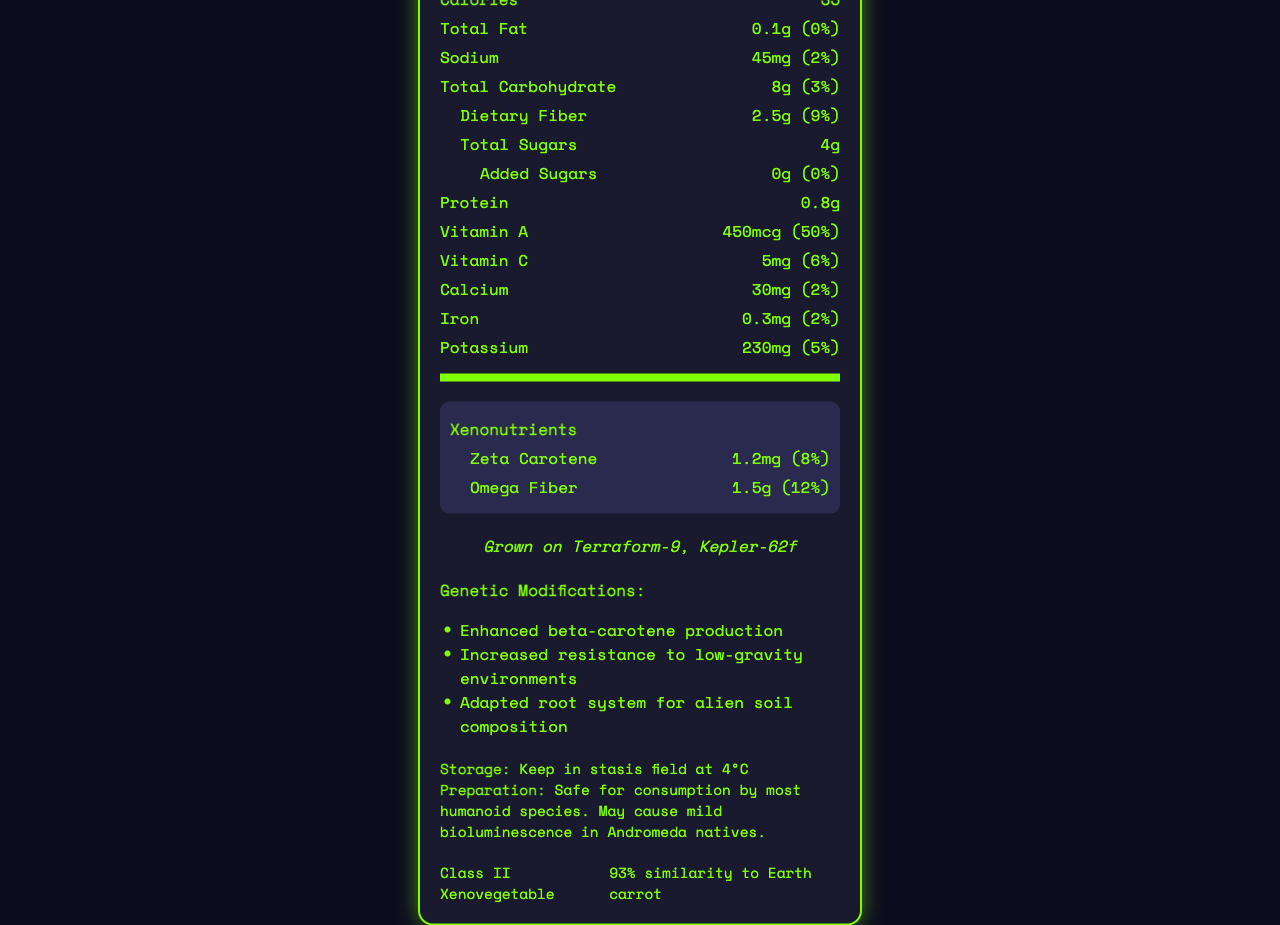what is the serving size for a Xenocarrot? Referring to the label, the serving size is clearly listed as "1 medium (85g)."
Answer: 1 medium (85g) how many calories are in one serving of a Xenocarrot? The document states that there are 35 calories in one serving of a Xenocarrot.
Answer: 35 what is the daily value percentage for dietary fiber per serving? The label shows that the dietary fiber content has a daily value percentage of 9%.
Answer: 9% which nutrient has the highest daily value percentage in a Xenocarrot? The document details various nutrients and their daily value percentages. Vitamin A has the highest at 50%.
Answer: Vitamin A what specific adaptation has been made to the Xenocarrot's root system? Under the genetic modifications section, the document lists "Adapted root system for alien soil composition."
Answer: Adapted root system for alien soil composition which planet is the Xenocarrot cultivated on? A. Terraform-9 B. Kepler-62f C. Mars D. Triton The document specifies that the Xenocarrot is "Grown on Terraform-9, Kepler-62f," indicating Terraform-9 is one of the cultivation locations, not just a planet.
Answer: A. Terraform-9 how much zeta carotene is in one serving, and what is its daily value percentage? A. 1.0mg, 6% B. 1.2mg, 10% C. 1.2mg, 8% D. 1.4mg, 12% The document notes that one serving contains 1.2mg of zeta carotene, which is 8% of the daily value.
Answer: C. 1.2mg, 8% can Andromeda natives safely consume the Xenocarrot without any side effects? The preparation suggestions mention that the Xenocarrot "May cause mild bioluminescence in Andromeda natives," indicating there are possible side effects.
Answer: No does the Xenocarrot have added sugars? According to the label, the Xenocarrot contains 0g of added sugars.
Answer: No summarize the main nutritional information and special details of a Xenocarrot. The document furnishes comprehensive nutritional details, genetic modifications, and special characteristics of the Xenocarrot.
Answer: The Xenocarrot provides 35 calories per serving and contains various nutrients like Vitamin A, Vitamin C, Calcium, and Iron. It is genetically modified for enhanced beta-carotene production, resistance to low-gravity environments, and soil adaptation. It includes unique xenonutrients like zeta carotene and omega fiber. Grown on Terraform-9, this vegetable is for interstellar trade and has a 93% similarity to Earth carrots. how much potassium is found in one serving of Xenocarrot? The label indicates that there are 230mg of potassium per serving, which is 5% of the daily value.
Answer: 230mg what is the storage temperature mentioned for the Xenocarrot? A. 2°C B. 4°C C. 6°C D. 0°C The storage instructions specify to "Keep in stasis field at 4°C."
Answer: B. 4°C what is the Terra Equivalence Rating of the Xenocarrot? The document specifies that the Terra Equivalence Rating is 93%, showing its similarity to an Earth carrot.
Answer: 93% what is the protein content per serving of a Xenocarrot? According to the document, each serving contains 0.8g of protein.
Answer: 0.8g who can safely consume a Xenocarrot? The preparation suggestion notes it is "Safe for consumption by most humanoid species."
Answer: Most humanoid species which nutrient has a daily value of 6% in a Xenocarrot? The document lists that Vitamin C has a 6% daily value per serving of Xenocarrot.
Answer: Vitamin C what is the iron content and its daily value percentage in one serving of a Xenocarrot? The document notes that one serving contains 0.3mg of iron, which is 2% of the daily value.
Answer: 0.3mg, 2% who is the primary consumer of this product, given the interstellar trade classification? The document states the classification as "Class II Xenovegetable," but it does not specify who the primary consumers are.
Answer: Cannot be determined 